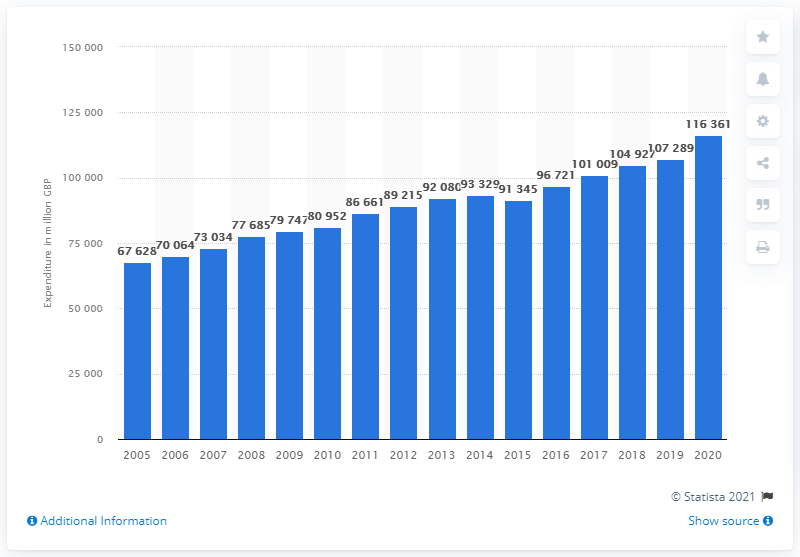Identify some key points in this picture. In 2020, the total consumer spending in the UK was 116,361 million pounds. 